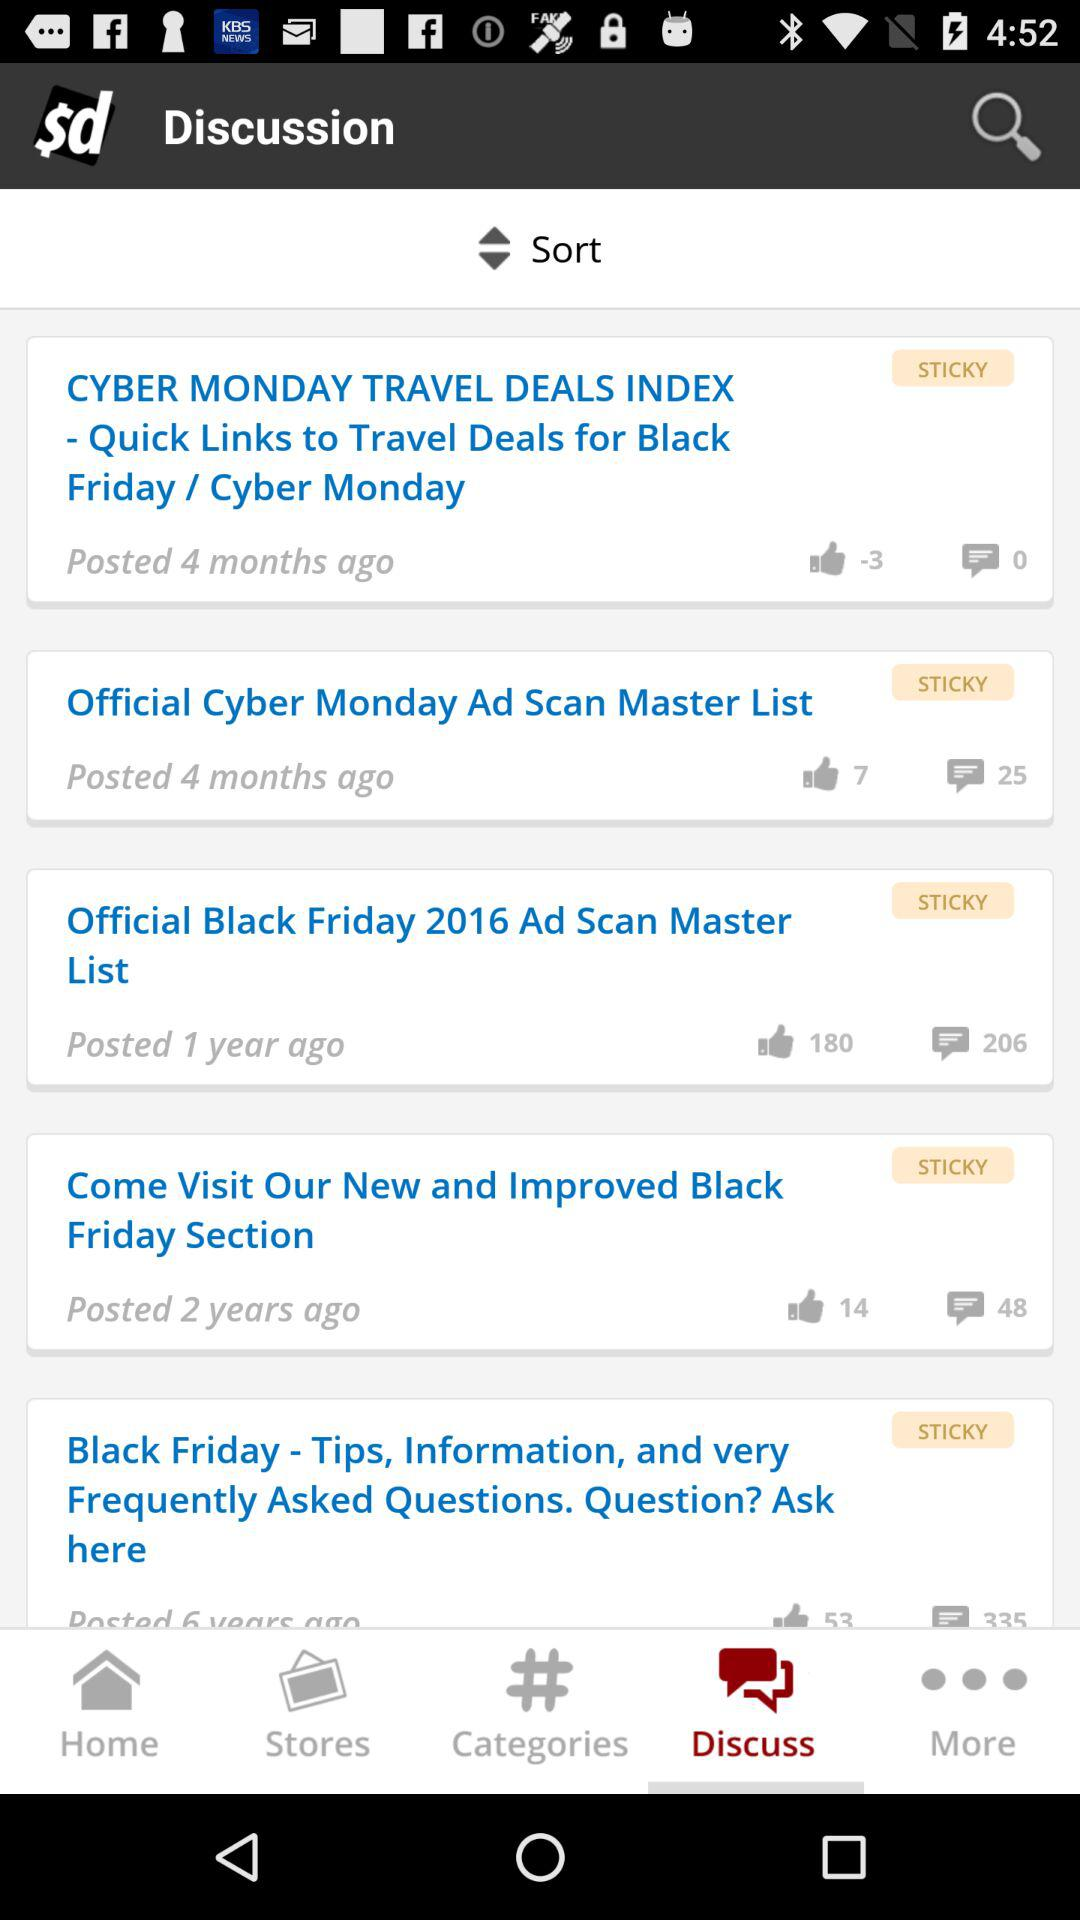How many months ago was the "CYBER MONDAY TRAVEL DEALS INDEX" posted? The "CYBER MONDAY TRAVEL DEALS INDEX" was posted 4 months ago. 